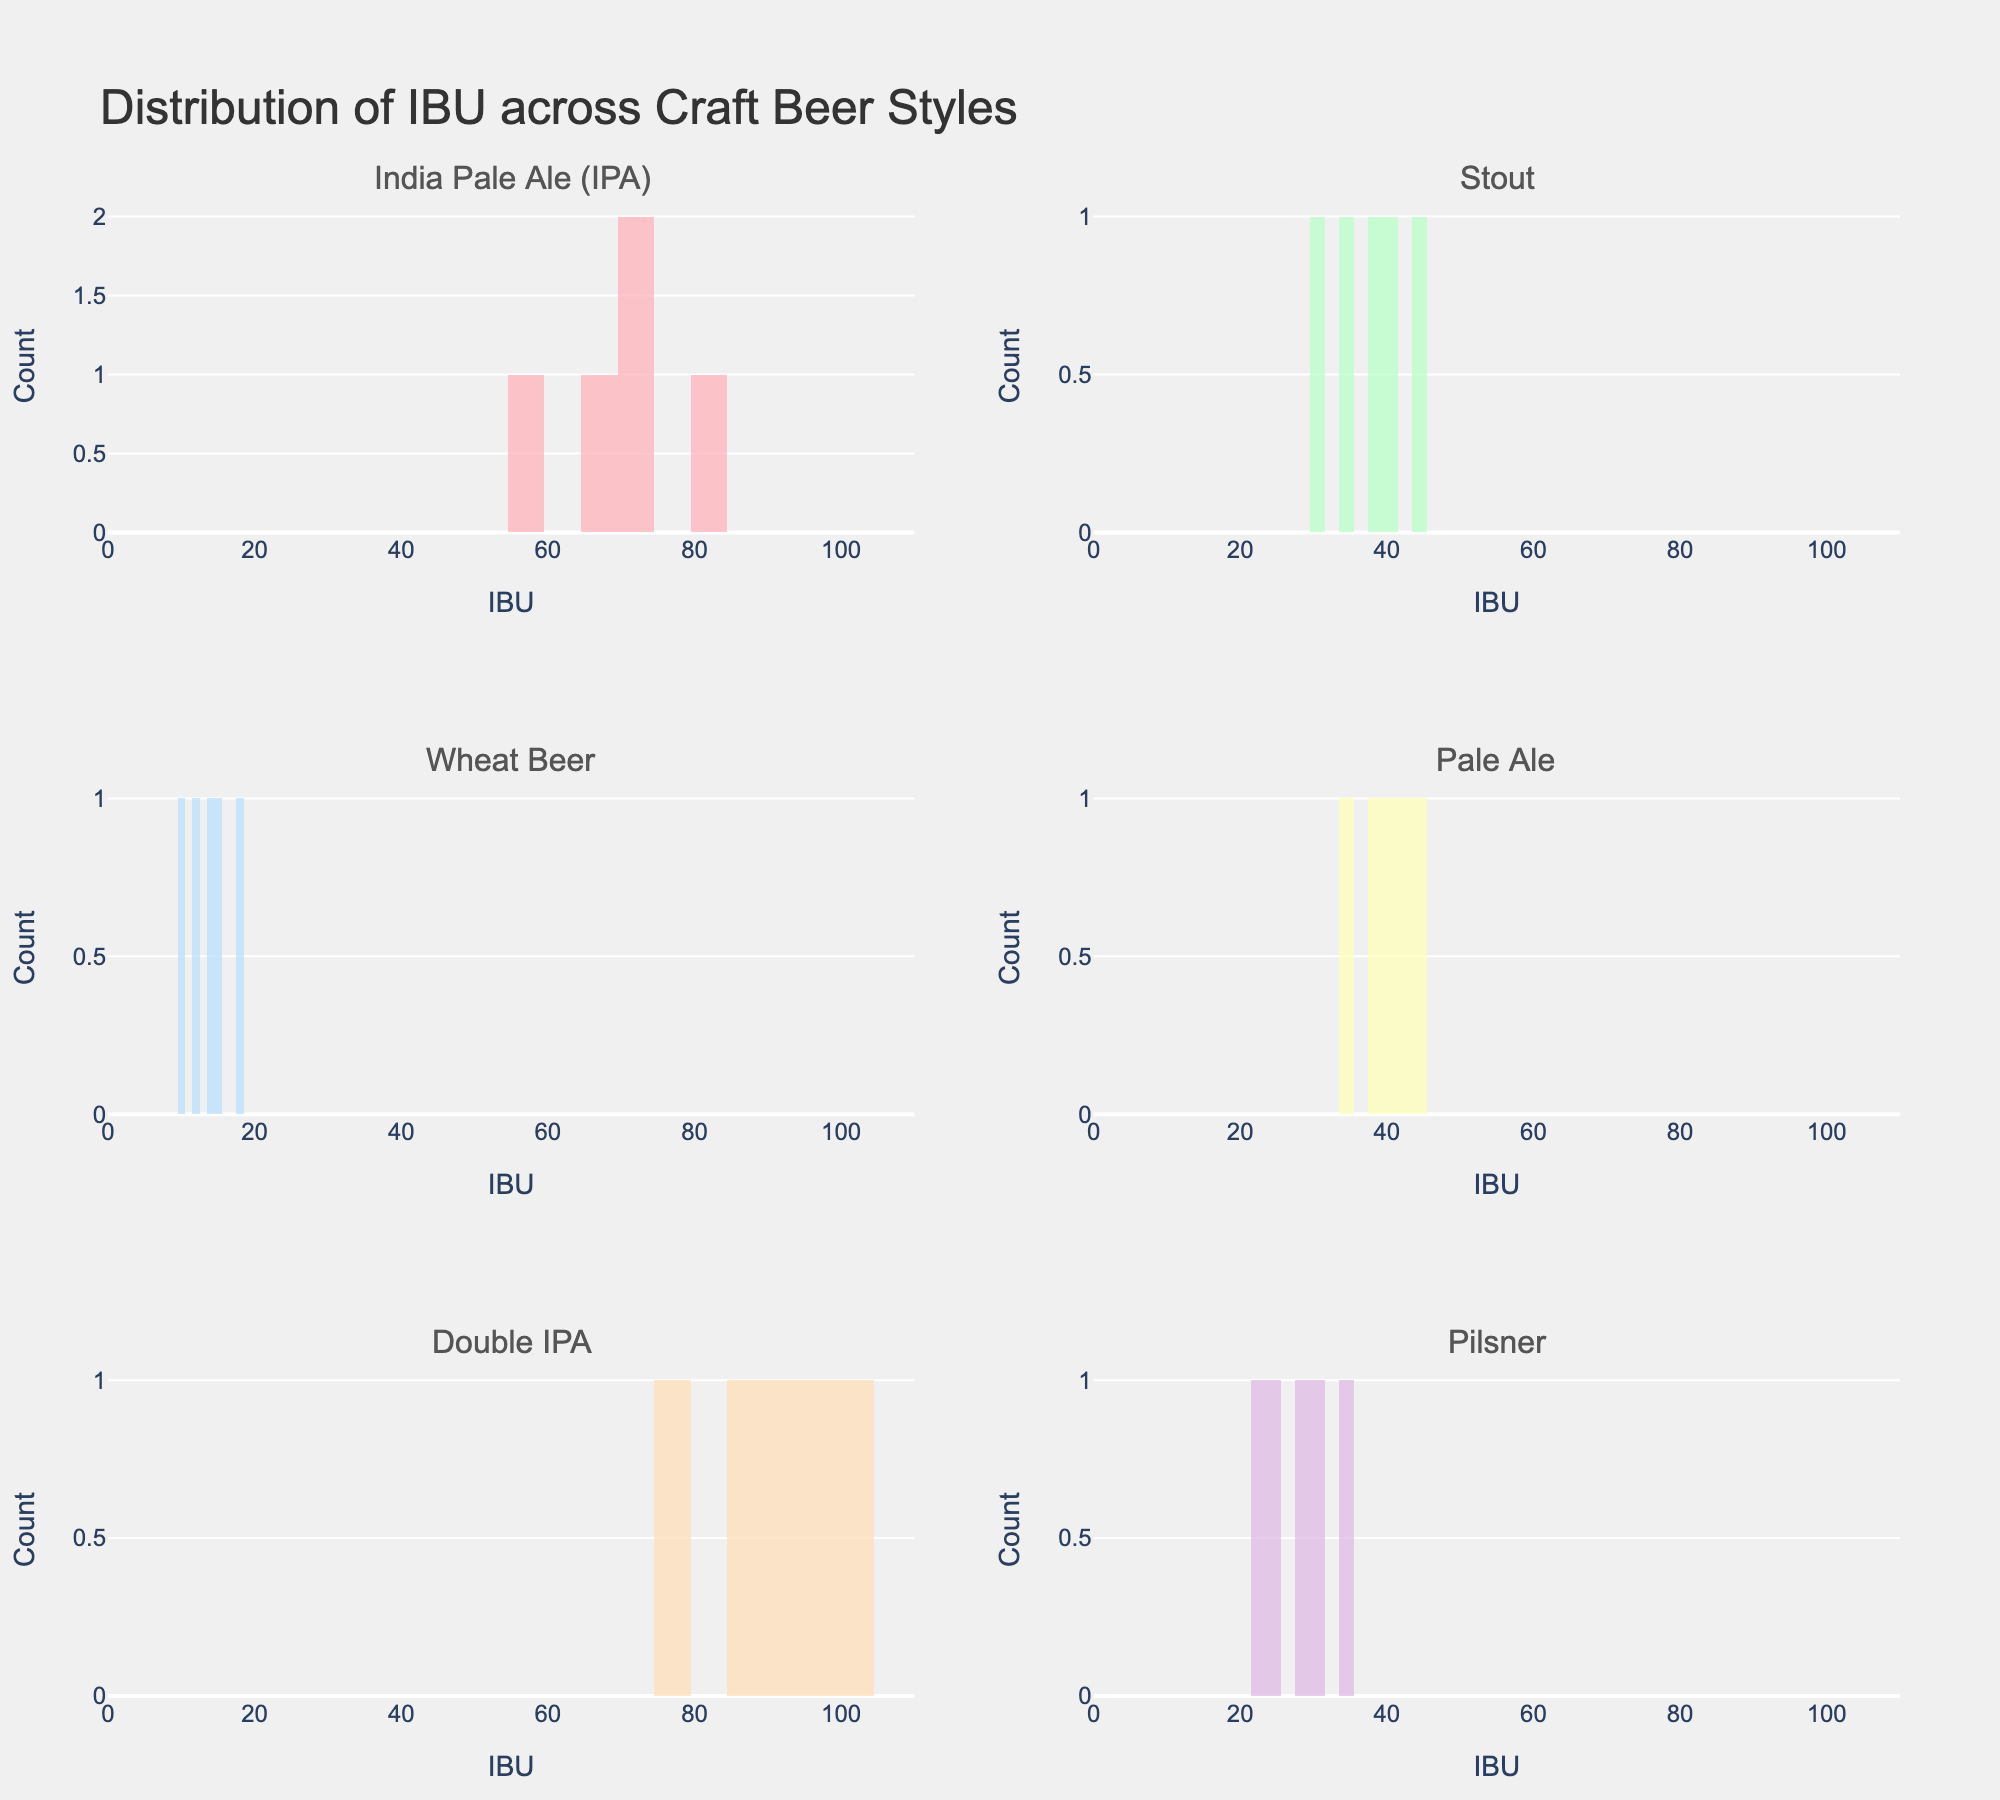What is the title of the plot? The title is usually found at the top of the plot. Here, it reads 'Distribution of IBU across Craft Beer Styles'.
Answer: Distribution of IBU across Craft Beer Styles Which beer style has the highest range of IBU values? The range can be determined by comparing the min and max IBU values for each subplot. Double IPA has a range from 78 to 100, which is the highest compared to other styles.
Answer: Double IPA How many subplots are in the figure? Counting the individual histograms for each beer style, we see there are six subplots.
Answer: 6 What is the lowest IBU value observed across all beer styles? The lowest IBU can be found in the Wheat Beer subplot, where the minimum value is 10.
Answer: 10 Which beer style has the most concentrated IBU range? The range of IBU for Wheat Beer is from 10 to 18, which is the most concentrated compared to other styles.
Answer: Wheat Beer Compare the IBU distributions of IPA and Stout. Which one has a wider variation? IPA ranges from 58 to 80, while Stout ranges from 30 to 45. IPA has a wider variation.
Answer: IPA Are there any beer styles with an IBU value of 65? By looking at each histogram, we see that an IBU value of 65 appears in the IPA style.
Answer: Yes What's the median IBU value for Pilsner? The IBU values for Pilsner are 25, 30, 22, 35, and 28. Arranging these in ascending order: 22, 25, 28, 30, 35, the median value is 28.
Answer: 28 Which subplots use a blue color? Identifying the colors by visual inspection, the Pilsner subplot uses the blue color.
Answer: Pilsner 